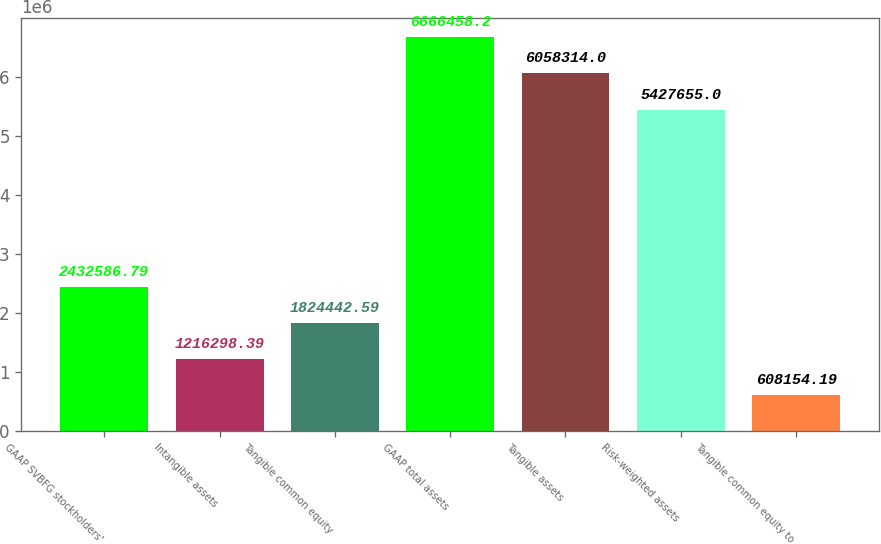Convert chart. <chart><loc_0><loc_0><loc_500><loc_500><bar_chart><fcel>GAAP SVBFG stockholders'<fcel>Intangible assets<fcel>Tangible common equity<fcel>GAAP total assets<fcel>Tangible assets<fcel>Risk-weighted assets<fcel>Tangible common equity to<nl><fcel>2.43259e+06<fcel>1.2163e+06<fcel>1.82444e+06<fcel>6.66646e+06<fcel>6.05831e+06<fcel>5.42766e+06<fcel>608154<nl></chart> 